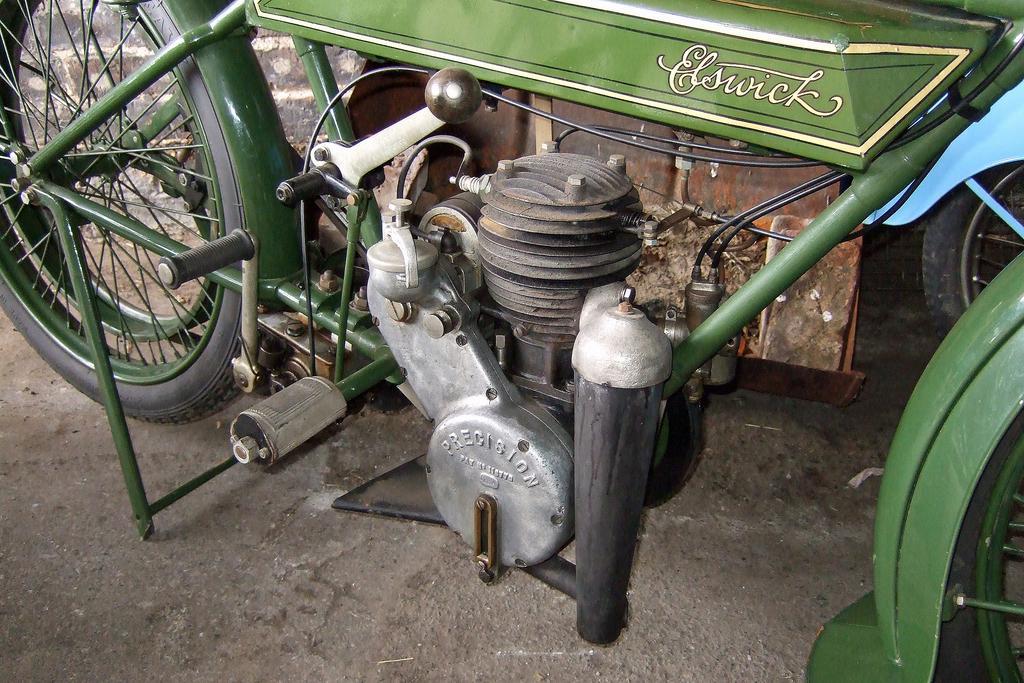Can you describe this image briefly? In this image we can see a motorbike which is in green color and there is some text on it and we can see the wheels and other parts of the motorbike and there is an another vehicle in the background. 